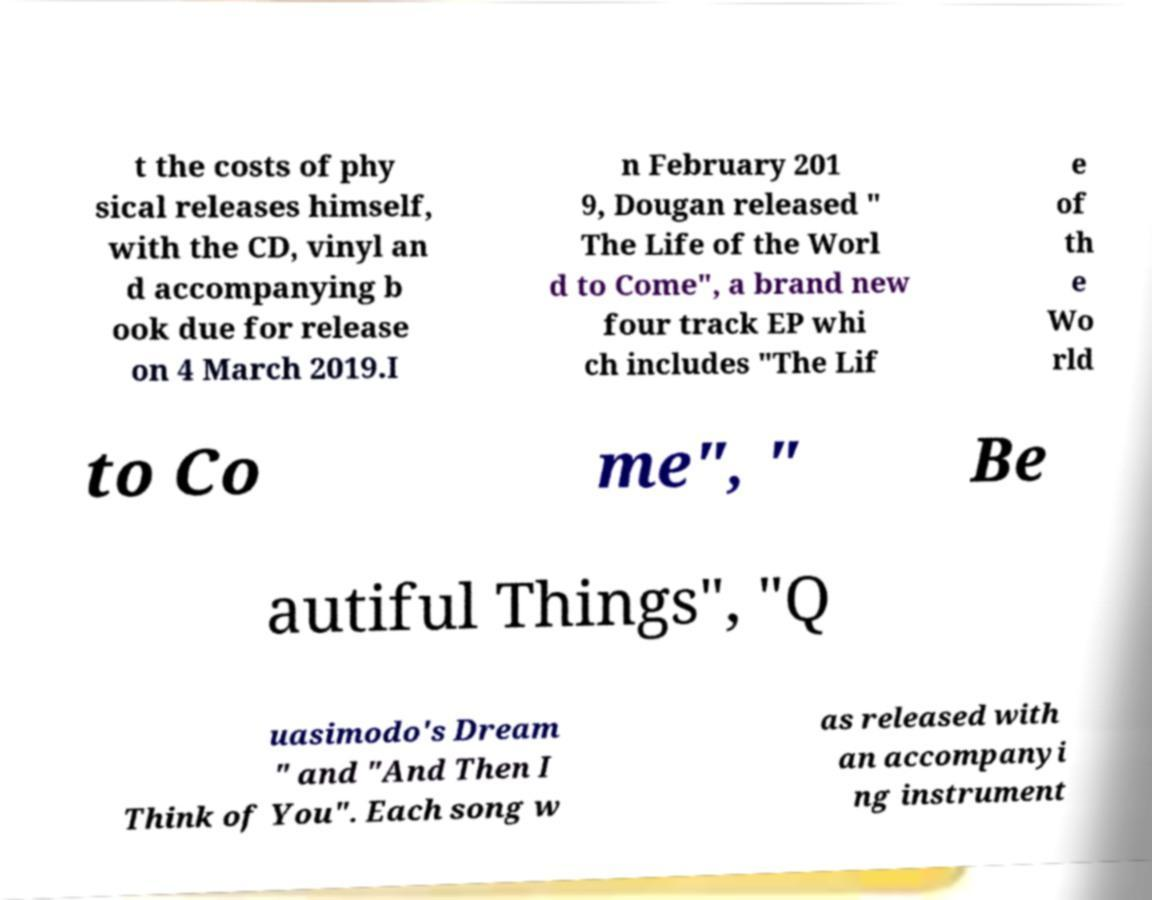Can you read and provide the text displayed in the image?This photo seems to have some interesting text. Can you extract and type it out for me? t the costs of phy sical releases himself, with the CD, vinyl an d accompanying b ook due for release on 4 March 2019.I n February 201 9, Dougan released " The Life of the Worl d to Come", a brand new four track EP whi ch includes "The Lif e of th e Wo rld to Co me", " Be autiful Things", "Q uasimodo's Dream " and "And Then I Think of You". Each song w as released with an accompanyi ng instrument 